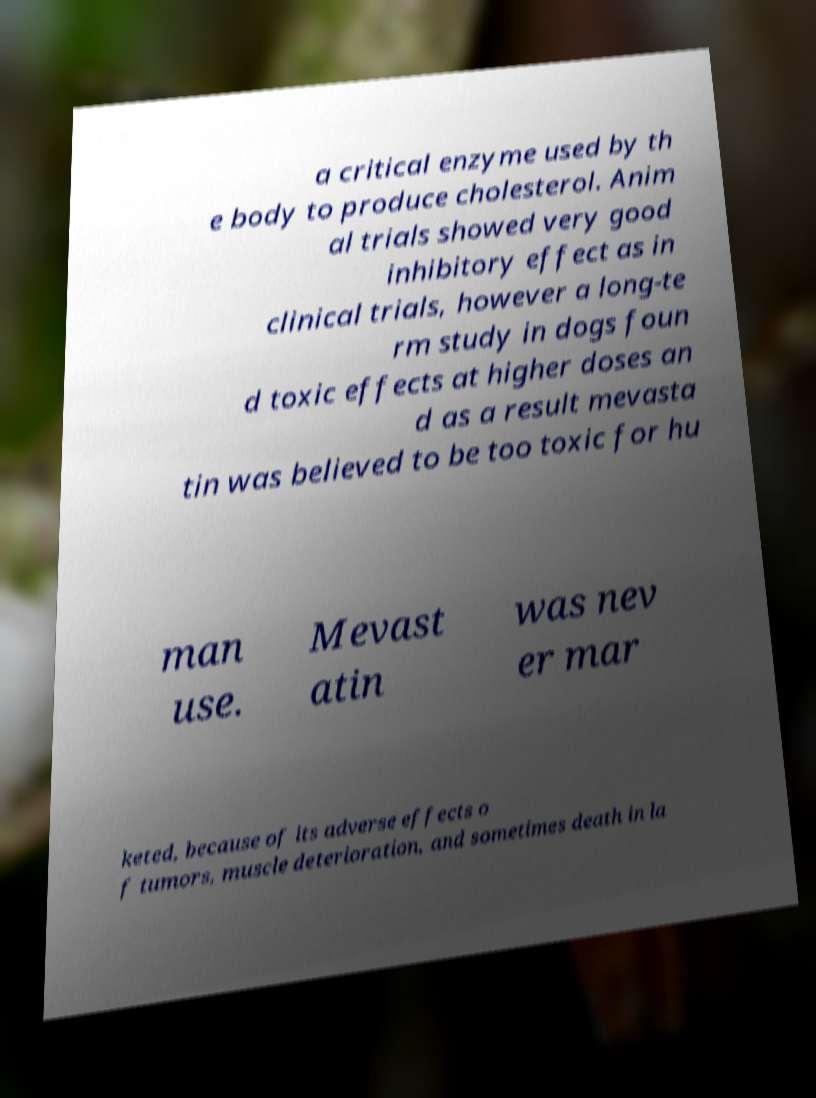Can you accurately transcribe the text from the provided image for me? a critical enzyme used by th e body to produce cholesterol. Anim al trials showed very good inhibitory effect as in clinical trials, however a long-te rm study in dogs foun d toxic effects at higher doses an d as a result mevasta tin was believed to be too toxic for hu man use. Mevast atin was nev er mar keted, because of its adverse effects o f tumors, muscle deterioration, and sometimes death in la 